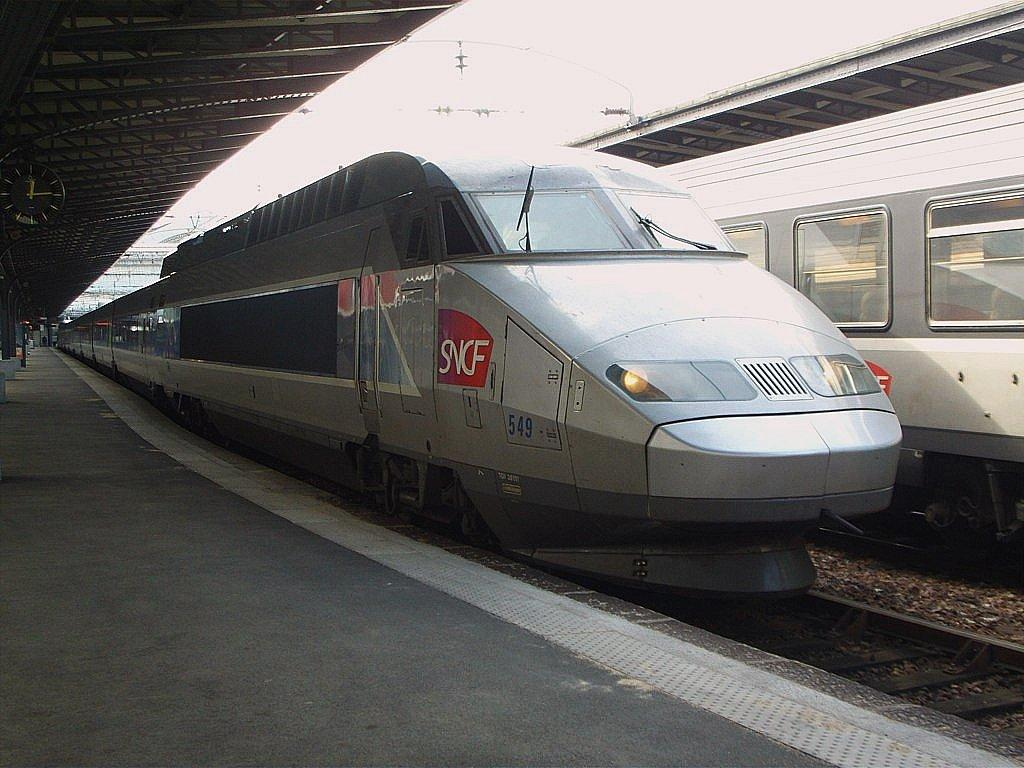<image>
Relay a brief, clear account of the picture shown. Gray and silver tran parked with the words SNCF on it. 